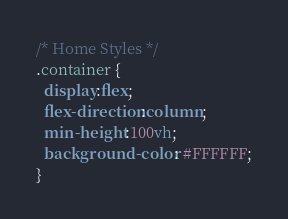Convert code to text. <code><loc_0><loc_0><loc_500><loc_500><_CSS_>/* Home Styles */
.container {
  display:flex;
  flex-direction:column;
  min-height:100vh;
  background-color: #FFFFFF;
}
</code> 